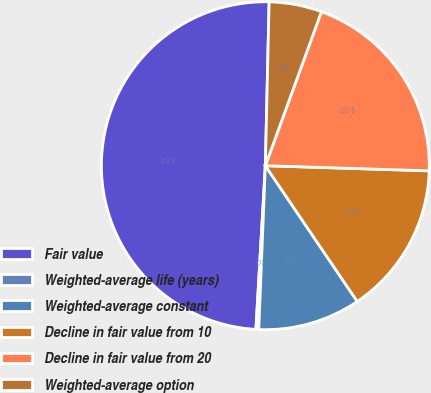<chart> <loc_0><loc_0><loc_500><loc_500><pie_chart><fcel>Fair value<fcel>Weighted-average life (years)<fcel>Weighted-average constant<fcel>Decline in fair value from 10<fcel>Decline in fair value from 20<fcel>Weighted-average option<nl><fcel>49.45%<fcel>0.28%<fcel>10.11%<fcel>15.03%<fcel>19.94%<fcel>5.19%<nl></chart> 